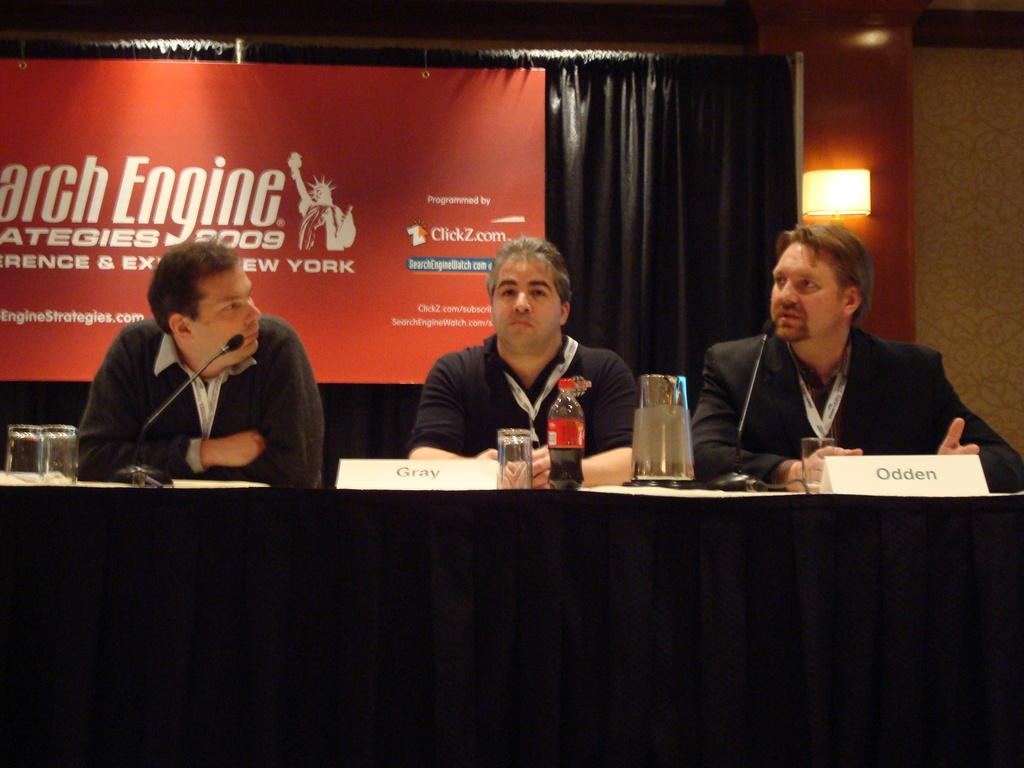<image>
Write a terse but informative summary of the picture. a man sitting in front of a name tag with Odden on it 